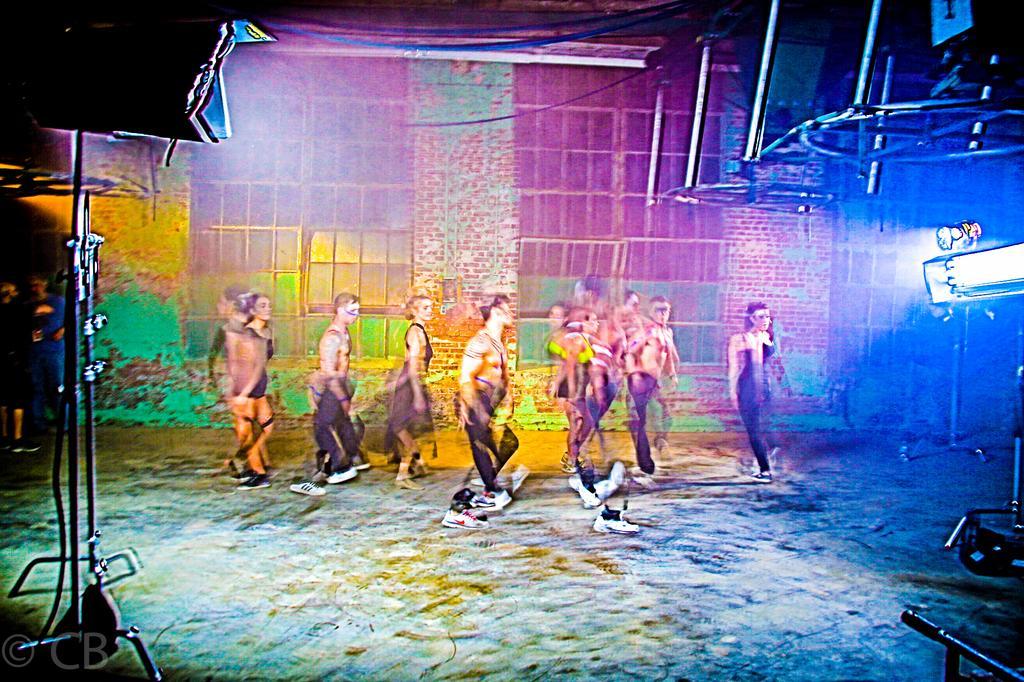Describe this image in one or two sentences. In this image I can see some people. In the background, I can see the wall. 